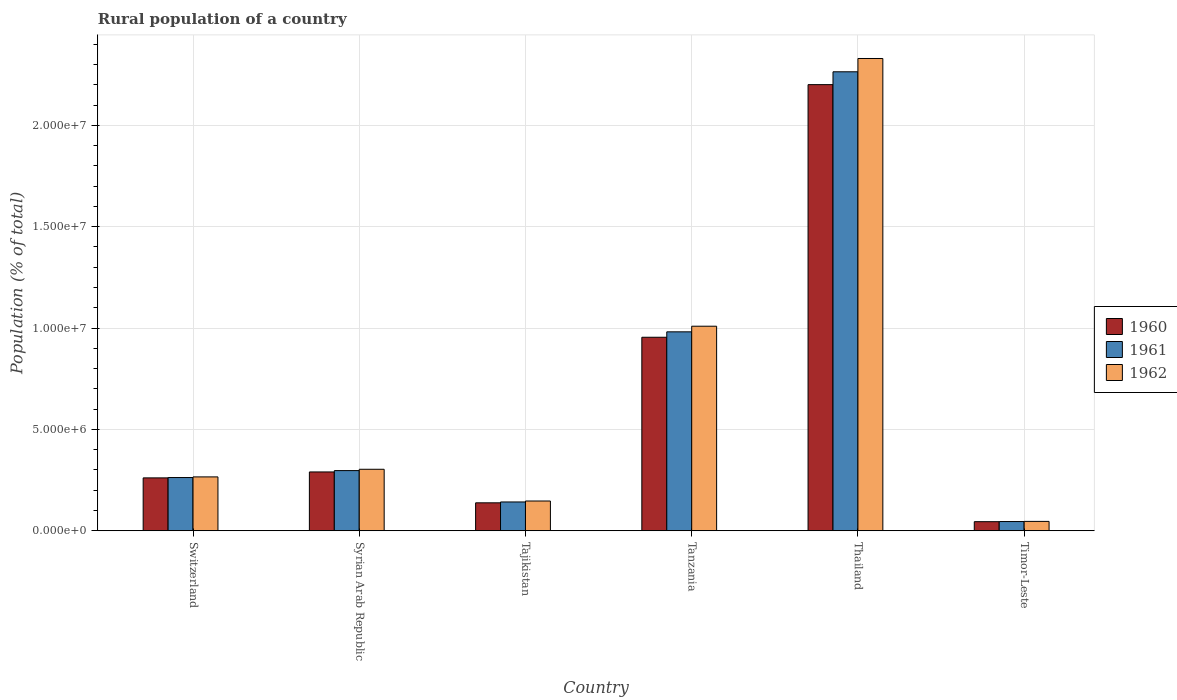How many bars are there on the 5th tick from the left?
Ensure brevity in your answer.  3. What is the label of the 4th group of bars from the left?
Offer a terse response. Tanzania. What is the rural population in 1960 in Switzerland?
Your response must be concise. 2.61e+06. Across all countries, what is the maximum rural population in 1961?
Your answer should be very brief. 2.26e+07. Across all countries, what is the minimum rural population in 1962?
Your answer should be very brief. 4.63e+05. In which country was the rural population in 1962 maximum?
Give a very brief answer. Thailand. In which country was the rural population in 1962 minimum?
Keep it short and to the point. Timor-Leste. What is the total rural population in 1960 in the graph?
Ensure brevity in your answer.  3.89e+07. What is the difference between the rural population in 1962 in Tajikistan and that in Timor-Leste?
Make the answer very short. 1.01e+06. What is the difference between the rural population in 1961 in Tajikistan and the rural population in 1960 in Timor-Leste?
Your answer should be compact. 9.73e+05. What is the average rural population in 1961 per country?
Offer a very short reply. 6.65e+06. What is the difference between the rural population of/in 1960 and rural population of/in 1961 in Switzerland?
Give a very brief answer. -1.67e+04. In how many countries, is the rural population in 1962 greater than 15000000 %?
Provide a succinct answer. 1. What is the ratio of the rural population in 1961 in Switzerland to that in Thailand?
Keep it short and to the point. 0.12. Is the rural population in 1961 in Tajikistan less than that in Tanzania?
Your response must be concise. Yes. What is the difference between the highest and the second highest rural population in 1961?
Make the answer very short. -1.28e+07. What is the difference between the highest and the lowest rural population in 1961?
Offer a terse response. 2.22e+07. In how many countries, is the rural population in 1960 greater than the average rural population in 1960 taken over all countries?
Offer a very short reply. 2. Is the sum of the rural population in 1961 in Tajikistan and Tanzania greater than the maximum rural population in 1962 across all countries?
Your response must be concise. No. What does the 2nd bar from the right in Switzerland represents?
Your response must be concise. 1961. How many bars are there?
Your response must be concise. 18. Are all the bars in the graph horizontal?
Make the answer very short. No. How many countries are there in the graph?
Provide a short and direct response. 6. Does the graph contain any zero values?
Offer a terse response. No. Does the graph contain grids?
Keep it short and to the point. Yes. Where does the legend appear in the graph?
Provide a succinct answer. Center right. How are the legend labels stacked?
Provide a short and direct response. Vertical. What is the title of the graph?
Offer a very short reply. Rural population of a country. Does "1971" appear as one of the legend labels in the graph?
Your response must be concise. No. What is the label or title of the X-axis?
Provide a short and direct response. Country. What is the label or title of the Y-axis?
Ensure brevity in your answer.  Population (% of total). What is the Population (% of total) in 1960 in Switzerland?
Your answer should be very brief. 2.61e+06. What is the Population (% of total) of 1961 in Switzerland?
Give a very brief answer. 2.63e+06. What is the Population (% of total) of 1962 in Switzerland?
Ensure brevity in your answer.  2.66e+06. What is the Population (% of total) of 1960 in Syrian Arab Republic?
Offer a very short reply. 2.90e+06. What is the Population (% of total) of 1961 in Syrian Arab Republic?
Ensure brevity in your answer.  2.97e+06. What is the Population (% of total) of 1962 in Syrian Arab Republic?
Your answer should be compact. 3.03e+06. What is the Population (% of total) in 1960 in Tajikistan?
Provide a short and direct response. 1.38e+06. What is the Population (% of total) in 1961 in Tajikistan?
Make the answer very short. 1.42e+06. What is the Population (% of total) of 1962 in Tajikistan?
Keep it short and to the point. 1.47e+06. What is the Population (% of total) of 1960 in Tanzania?
Offer a terse response. 9.55e+06. What is the Population (% of total) of 1961 in Tanzania?
Provide a succinct answer. 9.81e+06. What is the Population (% of total) of 1962 in Tanzania?
Ensure brevity in your answer.  1.01e+07. What is the Population (% of total) in 1960 in Thailand?
Provide a succinct answer. 2.20e+07. What is the Population (% of total) of 1961 in Thailand?
Provide a succinct answer. 2.26e+07. What is the Population (% of total) of 1962 in Thailand?
Your response must be concise. 2.33e+07. What is the Population (% of total) in 1960 in Timor-Leste?
Your response must be concise. 4.49e+05. What is the Population (% of total) in 1961 in Timor-Leste?
Ensure brevity in your answer.  4.56e+05. What is the Population (% of total) in 1962 in Timor-Leste?
Offer a terse response. 4.63e+05. Across all countries, what is the maximum Population (% of total) of 1960?
Make the answer very short. 2.20e+07. Across all countries, what is the maximum Population (% of total) of 1961?
Make the answer very short. 2.26e+07. Across all countries, what is the maximum Population (% of total) in 1962?
Your answer should be compact. 2.33e+07. Across all countries, what is the minimum Population (% of total) in 1960?
Provide a short and direct response. 4.49e+05. Across all countries, what is the minimum Population (% of total) in 1961?
Provide a succinct answer. 4.56e+05. Across all countries, what is the minimum Population (% of total) in 1962?
Your answer should be very brief. 4.63e+05. What is the total Population (% of total) in 1960 in the graph?
Your answer should be compact. 3.89e+07. What is the total Population (% of total) in 1961 in the graph?
Make the answer very short. 3.99e+07. What is the total Population (% of total) of 1962 in the graph?
Make the answer very short. 4.10e+07. What is the difference between the Population (% of total) in 1960 in Switzerland and that in Syrian Arab Republic?
Give a very brief answer. -2.93e+05. What is the difference between the Population (% of total) of 1961 in Switzerland and that in Syrian Arab Republic?
Provide a succinct answer. -3.43e+05. What is the difference between the Population (% of total) of 1962 in Switzerland and that in Syrian Arab Republic?
Offer a very short reply. -3.76e+05. What is the difference between the Population (% of total) of 1960 in Switzerland and that in Tajikistan?
Make the answer very short. 1.23e+06. What is the difference between the Population (% of total) in 1961 in Switzerland and that in Tajikistan?
Provide a succinct answer. 1.20e+06. What is the difference between the Population (% of total) in 1962 in Switzerland and that in Tajikistan?
Your answer should be very brief. 1.19e+06. What is the difference between the Population (% of total) in 1960 in Switzerland and that in Tanzania?
Provide a short and direct response. -6.94e+06. What is the difference between the Population (% of total) of 1961 in Switzerland and that in Tanzania?
Make the answer very short. -7.19e+06. What is the difference between the Population (% of total) in 1962 in Switzerland and that in Tanzania?
Your response must be concise. -7.43e+06. What is the difference between the Population (% of total) of 1960 in Switzerland and that in Thailand?
Offer a terse response. -1.94e+07. What is the difference between the Population (% of total) of 1961 in Switzerland and that in Thailand?
Your response must be concise. -2.00e+07. What is the difference between the Population (% of total) of 1962 in Switzerland and that in Thailand?
Give a very brief answer. -2.06e+07. What is the difference between the Population (% of total) in 1960 in Switzerland and that in Timor-Leste?
Offer a terse response. 2.16e+06. What is the difference between the Population (% of total) in 1961 in Switzerland and that in Timor-Leste?
Make the answer very short. 2.17e+06. What is the difference between the Population (% of total) in 1962 in Switzerland and that in Timor-Leste?
Keep it short and to the point. 2.20e+06. What is the difference between the Population (% of total) of 1960 in Syrian Arab Republic and that in Tajikistan?
Give a very brief answer. 1.52e+06. What is the difference between the Population (% of total) in 1961 in Syrian Arab Republic and that in Tajikistan?
Give a very brief answer. 1.55e+06. What is the difference between the Population (% of total) of 1962 in Syrian Arab Republic and that in Tajikistan?
Ensure brevity in your answer.  1.57e+06. What is the difference between the Population (% of total) in 1960 in Syrian Arab Republic and that in Tanzania?
Your answer should be very brief. -6.64e+06. What is the difference between the Population (% of total) in 1961 in Syrian Arab Republic and that in Tanzania?
Offer a terse response. -6.84e+06. What is the difference between the Population (% of total) in 1962 in Syrian Arab Republic and that in Tanzania?
Ensure brevity in your answer.  -7.06e+06. What is the difference between the Population (% of total) of 1960 in Syrian Arab Republic and that in Thailand?
Give a very brief answer. -1.91e+07. What is the difference between the Population (% of total) in 1961 in Syrian Arab Republic and that in Thailand?
Your answer should be very brief. -1.97e+07. What is the difference between the Population (% of total) of 1962 in Syrian Arab Republic and that in Thailand?
Offer a very short reply. -2.03e+07. What is the difference between the Population (% of total) of 1960 in Syrian Arab Republic and that in Timor-Leste?
Your answer should be very brief. 2.45e+06. What is the difference between the Population (% of total) of 1961 in Syrian Arab Republic and that in Timor-Leste?
Your answer should be compact. 2.51e+06. What is the difference between the Population (% of total) of 1962 in Syrian Arab Republic and that in Timor-Leste?
Your answer should be very brief. 2.57e+06. What is the difference between the Population (% of total) in 1960 in Tajikistan and that in Tanzania?
Provide a succinct answer. -8.17e+06. What is the difference between the Population (% of total) in 1961 in Tajikistan and that in Tanzania?
Your answer should be compact. -8.39e+06. What is the difference between the Population (% of total) in 1962 in Tajikistan and that in Tanzania?
Your response must be concise. -8.62e+06. What is the difference between the Population (% of total) in 1960 in Tajikistan and that in Thailand?
Offer a terse response. -2.06e+07. What is the difference between the Population (% of total) in 1961 in Tajikistan and that in Thailand?
Provide a short and direct response. -2.12e+07. What is the difference between the Population (% of total) in 1962 in Tajikistan and that in Thailand?
Your response must be concise. -2.18e+07. What is the difference between the Population (% of total) in 1960 in Tajikistan and that in Timor-Leste?
Ensure brevity in your answer.  9.30e+05. What is the difference between the Population (% of total) of 1961 in Tajikistan and that in Timor-Leste?
Provide a short and direct response. 9.66e+05. What is the difference between the Population (% of total) of 1962 in Tajikistan and that in Timor-Leste?
Your answer should be compact. 1.01e+06. What is the difference between the Population (% of total) of 1960 in Tanzania and that in Thailand?
Provide a succinct answer. -1.25e+07. What is the difference between the Population (% of total) in 1961 in Tanzania and that in Thailand?
Offer a terse response. -1.28e+07. What is the difference between the Population (% of total) in 1962 in Tanzania and that in Thailand?
Your answer should be compact. -1.32e+07. What is the difference between the Population (% of total) in 1960 in Tanzania and that in Timor-Leste?
Keep it short and to the point. 9.10e+06. What is the difference between the Population (% of total) of 1961 in Tanzania and that in Timor-Leste?
Provide a succinct answer. 9.36e+06. What is the difference between the Population (% of total) of 1962 in Tanzania and that in Timor-Leste?
Your response must be concise. 9.63e+06. What is the difference between the Population (% of total) of 1960 in Thailand and that in Timor-Leste?
Give a very brief answer. 2.16e+07. What is the difference between the Population (% of total) in 1961 in Thailand and that in Timor-Leste?
Offer a very short reply. 2.22e+07. What is the difference between the Population (% of total) of 1962 in Thailand and that in Timor-Leste?
Your answer should be compact. 2.28e+07. What is the difference between the Population (% of total) in 1960 in Switzerland and the Population (% of total) in 1961 in Syrian Arab Republic?
Your answer should be very brief. -3.59e+05. What is the difference between the Population (% of total) in 1960 in Switzerland and the Population (% of total) in 1962 in Syrian Arab Republic?
Your answer should be very brief. -4.25e+05. What is the difference between the Population (% of total) in 1961 in Switzerland and the Population (% of total) in 1962 in Syrian Arab Republic?
Provide a short and direct response. -4.08e+05. What is the difference between the Population (% of total) in 1960 in Switzerland and the Population (% of total) in 1961 in Tajikistan?
Provide a short and direct response. 1.19e+06. What is the difference between the Population (% of total) of 1960 in Switzerland and the Population (% of total) of 1962 in Tajikistan?
Offer a terse response. 1.14e+06. What is the difference between the Population (% of total) of 1961 in Switzerland and the Population (% of total) of 1962 in Tajikistan?
Offer a very short reply. 1.16e+06. What is the difference between the Population (% of total) of 1960 in Switzerland and the Population (% of total) of 1961 in Tanzania?
Your answer should be very brief. -7.20e+06. What is the difference between the Population (% of total) of 1960 in Switzerland and the Population (% of total) of 1962 in Tanzania?
Your answer should be very brief. -7.48e+06. What is the difference between the Population (% of total) in 1961 in Switzerland and the Population (% of total) in 1962 in Tanzania?
Offer a terse response. -7.46e+06. What is the difference between the Population (% of total) of 1960 in Switzerland and the Population (% of total) of 1961 in Thailand?
Give a very brief answer. -2.00e+07. What is the difference between the Population (% of total) in 1960 in Switzerland and the Population (% of total) in 1962 in Thailand?
Your answer should be very brief. -2.07e+07. What is the difference between the Population (% of total) in 1961 in Switzerland and the Population (% of total) in 1962 in Thailand?
Your response must be concise. -2.07e+07. What is the difference between the Population (% of total) of 1960 in Switzerland and the Population (% of total) of 1961 in Timor-Leste?
Make the answer very short. 2.15e+06. What is the difference between the Population (% of total) in 1960 in Switzerland and the Population (% of total) in 1962 in Timor-Leste?
Provide a succinct answer. 2.15e+06. What is the difference between the Population (% of total) in 1961 in Switzerland and the Population (% of total) in 1962 in Timor-Leste?
Offer a very short reply. 2.16e+06. What is the difference between the Population (% of total) in 1960 in Syrian Arab Republic and the Population (% of total) in 1961 in Tajikistan?
Provide a succinct answer. 1.48e+06. What is the difference between the Population (% of total) of 1960 in Syrian Arab Republic and the Population (% of total) of 1962 in Tajikistan?
Make the answer very short. 1.43e+06. What is the difference between the Population (% of total) in 1961 in Syrian Arab Republic and the Population (% of total) in 1962 in Tajikistan?
Give a very brief answer. 1.50e+06. What is the difference between the Population (% of total) of 1960 in Syrian Arab Republic and the Population (% of total) of 1961 in Tanzania?
Your response must be concise. -6.91e+06. What is the difference between the Population (% of total) of 1960 in Syrian Arab Republic and the Population (% of total) of 1962 in Tanzania?
Provide a short and direct response. -7.19e+06. What is the difference between the Population (% of total) of 1961 in Syrian Arab Republic and the Population (% of total) of 1962 in Tanzania?
Provide a short and direct response. -7.12e+06. What is the difference between the Population (% of total) in 1960 in Syrian Arab Republic and the Population (% of total) in 1961 in Thailand?
Give a very brief answer. -1.97e+07. What is the difference between the Population (% of total) of 1960 in Syrian Arab Republic and the Population (% of total) of 1962 in Thailand?
Your response must be concise. -2.04e+07. What is the difference between the Population (% of total) of 1961 in Syrian Arab Republic and the Population (% of total) of 1962 in Thailand?
Your answer should be very brief. -2.03e+07. What is the difference between the Population (% of total) of 1960 in Syrian Arab Republic and the Population (% of total) of 1961 in Timor-Leste?
Provide a short and direct response. 2.45e+06. What is the difference between the Population (% of total) of 1960 in Syrian Arab Republic and the Population (% of total) of 1962 in Timor-Leste?
Make the answer very short. 2.44e+06. What is the difference between the Population (% of total) of 1961 in Syrian Arab Republic and the Population (% of total) of 1962 in Timor-Leste?
Your answer should be compact. 2.51e+06. What is the difference between the Population (% of total) in 1960 in Tajikistan and the Population (% of total) in 1961 in Tanzania?
Provide a short and direct response. -8.43e+06. What is the difference between the Population (% of total) of 1960 in Tajikistan and the Population (% of total) of 1962 in Tanzania?
Give a very brief answer. -8.71e+06. What is the difference between the Population (% of total) of 1961 in Tajikistan and the Population (% of total) of 1962 in Tanzania?
Offer a terse response. -8.67e+06. What is the difference between the Population (% of total) of 1960 in Tajikistan and the Population (% of total) of 1961 in Thailand?
Provide a short and direct response. -2.13e+07. What is the difference between the Population (% of total) in 1960 in Tajikistan and the Population (% of total) in 1962 in Thailand?
Keep it short and to the point. -2.19e+07. What is the difference between the Population (% of total) in 1961 in Tajikistan and the Population (% of total) in 1962 in Thailand?
Your answer should be compact. -2.19e+07. What is the difference between the Population (% of total) of 1960 in Tajikistan and the Population (% of total) of 1961 in Timor-Leste?
Provide a short and direct response. 9.23e+05. What is the difference between the Population (% of total) of 1960 in Tajikistan and the Population (% of total) of 1962 in Timor-Leste?
Keep it short and to the point. 9.16e+05. What is the difference between the Population (% of total) of 1961 in Tajikistan and the Population (% of total) of 1962 in Timor-Leste?
Give a very brief answer. 9.59e+05. What is the difference between the Population (% of total) of 1960 in Tanzania and the Population (% of total) of 1961 in Thailand?
Your response must be concise. -1.31e+07. What is the difference between the Population (% of total) of 1960 in Tanzania and the Population (% of total) of 1962 in Thailand?
Your response must be concise. -1.38e+07. What is the difference between the Population (% of total) of 1961 in Tanzania and the Population (% of total) of 1962 in Thailand?
Your answer should be compact. -1.35e+07. What is the difference between the Population (% of total) in 1960 in Tanzania and the Population (% of total) in 1961 in Timor-Leste?
Make the answer very short. 9.09e+06. What is the difference between the Population (% of total) of 1960 in Tanzania and the Population (% of total) of 1962 in Timor-Leste?
Provide a succinct answer. 9.08e+06. What is the difference between the Population (% of total) of 1961 in Tanzania and the Population (% of total) of 1962 in Timor-Leste?
Offer a very short reply. 9.35e+06. What is the difference between the Population (% of total) in 1960 in Thailand and the Population (% of total) in 1961 in Timor-Leste?
Keep it short and to the point. 2.16e+07. What is the difference between the Population (% of total) of 1960 in Thailand and the Population (% of total) of 1962 in Timor-Leste?
Make the answer very short. 2.15e+07. What is the difference between the Population (% of total) in 1961 in Thailand and the Population (% of total) in 1962 in Timor-Leste?
Your response must be concise. 2.22e+07. What is the average Population (% of total) of 1960 per country?
Your answer should be compact. 6.48e+06. What is the average Population (% of total) in 1961 per country?
Provide a short and direct response. 6.65e+06. What is the average Population (% of total) of 1962 per country?
Give a very brief answer. 6.84e+06. What is the difference between the Population (% of total) in 1960 and Population (% of total) in 1961 in Switzerland?
Make the answer very short. -1.67e+04. What is the difference between the Population (% of total) of 1960 and Population (% of total) of 1962 in Switzerland?
Offer a very short reply. -4.86e+04. What is the difference between the Population (% of total) in 1961 and Population (% of total) in 1962 in Switzerland?
Give a very brief answer. -3.19e+04. What is the difference between the Population (% of total) in 1960 and Population (% of total) in 1961 in Syrian Arab Republic?
Make the answer very short. -6.66e+04. What is the difference between the Population (% of total) in 1960 and Population (% of total) in 1962 in Syrian Arab Republic?
Provide a succinct answer. -1.32e+05. What is the difference between the Population (% of total) of 1961 and Population (% of total) of 1962 in Syrian Arab Republic?
Keep it short and to the point. -6.53e+04. What is the difference between the Population (% of total) in 1960 and Population (% of total) in 1961 in Tajikistan?
Provide a short and direct response. -4.27e+04. What is the difference between the Population (% of total) of 1960 and Population (% of total) of 1962 in Tajikistan?
Provide a short and direct response. -8.94e+04. What is the difference between the Population (% of total) in 1961 and Population (% of total) in 1962 in Tajikistan?
Offer a very short reply. -4.67e+04. What is the difference between the Population (% of total) in 1960 and Population (% of total) in 1961 in Tanzania?
Offer a terse response. -2.68e+05. What is the difference between the Population (% of total) in 1960 and Population (% of total) in 1962 in Tanzania?
Provide a succinct answer. -5.45e+05. What is the difference between the Population (% of total) of 1961 and Population (% of total) of 1962 in Tanzania?
Offer a terse response. -2.77e+05. What is the difference between the Population (% of total) of 1960 and Population (% of total) of 1961 in Thailand?
Provide a succinct answer. -6.34e+05. What is the difference between the Population (% of total) of 1960 and Population (% of total) of 1962 in Thailand?
Your answer should be very brief. -1.29e+06. What is the difference between the Population (% of total) of 1961 and Population (% of total) of 1962 in Thailand?
Give a very brief answer. -6.56e+05. What is the difference between the Population (% of total) in 1960 and Population (% of total) in 1961 in Timor-Leste?
Provide a short and direct response. -7127. What is the difference between the Population (% of total) in 1960 and Population (% of total) in 1962 in Timor-Leste?
Make the answer very short. -1.39e+04. What is the difference between the Population (% of total) in 1961 and Population (% of total) in 1962 in Timor-Leste?
Offer a very short reply. -6812. What is the ratio of the Population (% of total) of 1960 in Switzerland to that in Syrian Arab Republic?
Ensure brevity in your answer.  0.9. What is the ratio of the Population (% of total) of 1961 in Switzerland to that in Syrian Arab Republic?
Keep it short and to the point. 0.88. What is the ratio of the Population (% of total) of 1962 in Switzerland to that in Syrian Arab Republic?
Provide a succinct answer. 0.88. What is the ratio of the Population (% of total) in 1960 in Switzerland to that in Tajikistan?
Keep it short and to the point. 1.89. What is the ratio of the Population (% of total) in 1961 in Switzerland to that in Tajikistan?
Your response must be concise. 1.85. What is the ratio of the Population (% of total) in 1962 in Switzerland to that in Tajikistan?
Your answer should be very brief. 1.81. What is the ratio of the Population (% of total) in 1960 in Switzerland to that in Tanzania?
Your response must be concise. 0.27. What is the ratio of the Population (% of total) of 1961 in Switzerland to that in Tanzania?
Your answer should be compact. 0.27. What is the ratio of the Population (% of total) in 1962 in Switzerland to that in Tanzania?
Offer a terse response. 0.26. What is the ratio of the Population (% of total) in 1960 in Switzerland to that in Thailand?
Ensure brevity in your answer.  0.12. What is the ratio of the Population (% of total) of 1961 in Switzerland to that in Thailand?
Ensure brevity in your answer.  0.12. What is the ratio of the Population (% of total) of 1962 in Switzerland to that in Thailand?
Your response must be concise. 0.11. What is the ratio of the Population (% of total) in 1960 in Switzerland to that in Timor-Leste?
Offer a very short reply. 5.81. What is the ratio of the Population (% of total) in 1961 in Switzerland to that in Timor-Leste?
Your answer should be very brief. 5.76. What is the ratio of the Population (% of total) of 1962 in Switzerland to that in Timor-Leste?
Give a very brief answer. 5.74. What is the ratio of the Population (% of total) of 1960 in Syrian Arab Republic to that in Tajikistan?
Provide a short and direct response. 2.1. What is the ratio of the Population (% of total) in 1961 in Syrian Arab Republic to that in Tajikistan?
Give a very brief answer. 2.09. What is the ratio of the Population (% of total) in 1962 in Syrian Arab Republic to that in Tajikistan?
Offer a terse response. 2.07. What is the ratio of the Population (% of total) in 1960 in Syrian Arab Republic to that in Tanzania?
Give a very brief answer. 0.3. What is the ratio of the Population (% of total) in 1961 in Syrian Arab Republic to that in Tanzania?
Your response must be concise. 0.3. What is the ratio of the Population (% of total) in 1962 in Syrian Arab Republic to that in Tanzania?
Make the answer very short. 0.3. What is the ratio of the Population (% of total) of 1960 in Syrian Arab Republic to that in Thailand?
Provide a succinct answer. 0.13. What is the ratio of the Population (% of total) of 1961 in Syrian Arab Republic to that in Thailand?
Provide a succinct answer. 0.13. What is the ratio of the Population (% of total) in 1962 in Syrian Arab Republic to that in Thailand?
Make the answer very short. 0.13. What is the ratio of the Population (% of total) of 1960 in Syrian Arab Republic to that in Timor-Leste?
Ensure brevity in your answer.  6.46. What is the ratio of the Population (% of total) of 1961 in Syrian Arab Republic to that in Timor-Leste?
Your answer should be very brief. 6.51. What is the ratio of the Population (% of total) of 1962 in Syrian Arab Republic to that in Timor-Leste?
Make the answer very short. 6.55. What is the ratio of the Population (% of total) in 1960 in Tajikistan to that in Tanzania?
Offer a very short reply. 0.14. What is the ratio of the Population (% of total) of 1961 in Tajikistan to that in Tanzania?
Make the answer very short. 0.14. What is the ratio of the Population (% of total) in 1962 in Tajikistan to that in Tanzania?
Give a very brief answer. 0.15. What is the ratio of the Population (% of total) of 1960 in Tajikistan to that in Thailand?
Offer a very short reply. 0.06. What is the ratio of the Population (% of total) in 1961 in Tajikistan to that in Thailand?
Your answer should be compact. 0.06. What is the ratio of the Population (% of total) in 1962 in Tajikistan to that in Thailand?
Your response must be concise. 0.06. What is the ratio of the Population (% of total) in 1960 in Tajikistan to that in Timor-Leste?
Offer a very short reply. 3.07. What is the ratio of the Population (% of total) of 1961 in Tajikistan to that in Timor-Leste?
Offer a terse response. 3.12. What is the ratio of the Population (% of total) in 1962 in Tajikistan to that in Timor-Leste?
Provide a short and direct response. 3.17. What is the ratio of the Population (% of total) of 1960 in Tanzania to that in Thailand?
Your response must be concise. 0.43. What is the ratio of the Population (% of total) of 1961 in Tanzania to that in Thailand?
Ensure brevity in your answer.  0.43. What is the ratio of the Population (% of total) in 1962 in Tanzania to that in Thailand?
Make the answer very short. 0.43. What is the ratio of the Population (% of total) of 1960 in Tanzania to that in Timor-Leste?
Your response must be concise. 21.25. What is the ratio of the Population (% of total) of 1961 in Tanzania to that in Timor-Leste?
Provide a succinct answer. 21.51. What is the ratio of the Population (% of total) of 1962 in Tanzania to that in Timor-Leste?
Keep it short and to the point. 21.79. What is the ratio of the Population (% of total) of 1960 in Thailand to that in Timor-Leste?
Your response must be concise. 49. What is the ratio of the Population (% of total) in 1961 in Thailand to that in Timor-Leste?
Your answer should be compact. 49.62. What is the ratio of the Population (% of total) in 1962 in Thailand to that in Timor-Leste?
Your answer should be very brief. 50.31. What is the difference between the highest and the second highest Population (% of total) of 1960?
Offer a very short reply. 1.25e+07. What is the difference between the highest and the second highest Population (% of total) in 1961?
Your response must be concise. 1.28e+07. What is the difference between the highest and the second highest Population (% of total) of 1962?
Make the answer very short. 1.32e+07. What is the difference between the highest and the lowest Population (% of total) in 1960?
Offer a terse response. 2.16e+07. What is the difference between the highest and the lowest Population (% of total) of 1961?
Your answer should be very brief. 2.22e+07. What is the difference between the highest and the lowest Population (% of total) in 1962?
Give a very brief answer. 2.28e+07. 